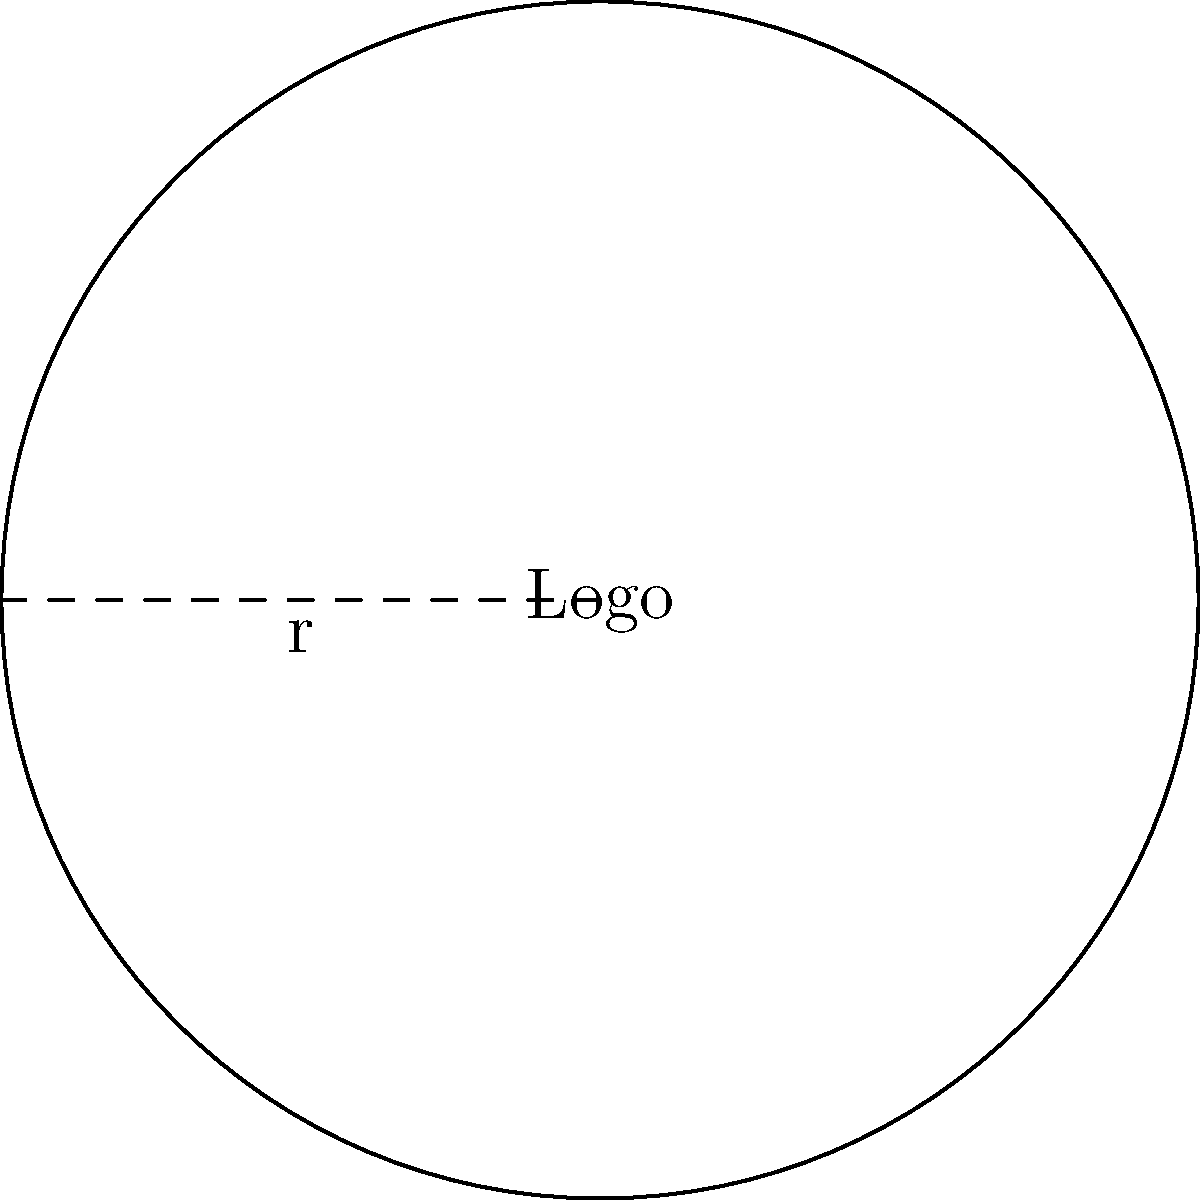A startup company wants to create a circular logo for their brand. The design team has proposed a logo with a radius of 12 inches. As a talent acquisition specialist, you need to estimate the area of this logo for printing purposes. What is the area of the circular logo in square inches? To find the area of a circular logo, we need to use the formula for the area of a circle:

$$A = \pi r^2$$

Where:
- $A$ is the area of the circle
- $\pi$ (pi) is approximately 3.14159
- $r$ is the radius of the circle

Given:
- Radius (r) = 12 inches

Let's calculate the area:

1. Substitute the values into the formula:
   $$A = \pi (12)^2$$

2. Calculate the square of the radius:
   $$A = \pi (144)$$

3. Multiply by pi:
   $$A = 452.39 \text{ square inches}$$

4. Round to two decimal places:
   $$A \approx 452.39 \text{ square inches}$$

Therefore, the area of the circular logo is approximately 452.39 square inches.
Answer: 452.39 square inches 